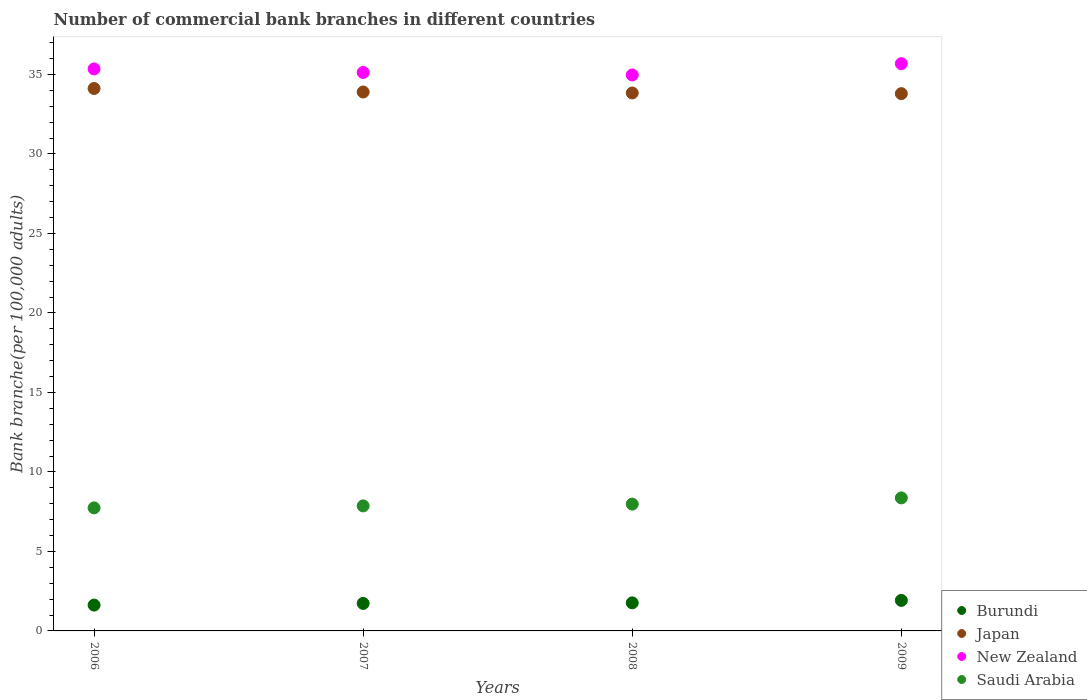Is the number of dotlines equal to the number of legend labels?
Your answer should be very brief. Yes. What is the number of commercial bank branches in Burundi in 2007?
Offer a very short reply. 1.73. Across all years, what is the maximum number of commercial bank branches in Japan?
Offer a terse response. 34.11. Across all years, what is the minimum number of commercial bank branches in Burundi?
Your response must be concise. 1.62. In which year was the number of commercial bank branches in Japan minimum?
Keep it short and to the point. 2009. What is the total number of commercial bank branches in Saudi Arabia in the graph?
Ensure brevity in your answer.  31.94. What is the difference between the number of commercial bank branches in New Zealand in 2008 and that in 2009?
Ensure brevity in your answer.  -0.71. What is the difference between the number of commercial bank branches in Burundi in 2006 and the number of commercial bank branches in Saudi Arabia in 2007?
Offer a very short reply. -6.24. What is the average number of commercial bank branches in Burundi per year?
Provide a short and direct response. 1.76. In the year 2009, what is the difference between the number of commercial bank branches in Japan and number of commercial bank branches in Saudi Arabia?
Your answer should be compact. 25.42. What is the ratio of the number of commercial bank branches in Burundi in 2007 to that in 2008?
Make the answer very short. 0.98. Is the difference between the number of commercial bank branches in Japan in 2007 and 2008 greater than the difference between the number of commercial bank branches in Saudi Arabia in 2007 and 2008?
Offer a very short reply. Yes. What is the difference between the highest and the second highest number of commercial bank branches in Burundi?
Your answer should be compact. 0.15. What is the difference between the highest and the lowest number of commercial bank branches in Saudi Arabia?
Make the answer very short. 0.63. In how many years, is the number of commercial bank branches in New Zealand greater than the average number of commercial bank branches in New Zealand taken over all years?
Your answer should be compact. 2. Is the sum of the number of commercial bank branches in Japan in 2007 and 2008 greater than the maximum number of commercial bank branches in New Zealand across all years?
Provide a short and direct response. Yes. Is it the case that in every year, the sum of the number of commercial bank branches in New Zealand and number of commercial bank branches in Japan  is greater than the sum of number of commercial bank branches in Saudi Arabia and number of commercial bank branches in Burundi?
Make the answer very short. Yes. Is it the case that in every year, the sum of the number of commercial bank branches in Saudi Arabia and number of commercial bank branches in New Zealand  is greater than the number of commercial bank branches in Burundi?
Offer a terse response. Yes. Does the number of commercial bank branches in Japan monotonically increase over the years?
Provide a short and direct response. No. Is the number of commercial bank branches in Japan strictly greater than the number of commercial bank branches in Burundi over the years?
Offer a very short reply. Yes. Is the number of commercial bank branches in New Zealand strictly less than the number of commercial bank branches in Japan over the years?
Provide a short and direct response. No. What is the difference between two consecutive major ticks on the Y-axis?
Your response must be concise. 5. Are the values on the major ticks of Y-axis written in scientific E-notation?
Offer a very short reply. No. What is the title of the graph?
Ensure brevity in your answer.  Number of commercial bank branches in different countries. What is the label or title of the Y-axis?
Your answer should be very brief. Bank branche(per 100,0 adults). What is the Bank branche(per 100,000 adults) of Burundi in 2006?
Your answer should be very brief. 1.62. What is the Bank branche(per 100,000 adults) of Japan in 2006?
Keep it short and to the point. 34.11. What is the Bank branche(per 100,000 adults) in New Zealand in 2006?
Provide a short and direct response. 35.34. What is the Bank branche(per 100,000 adults) in Saudi Arabia in 2006?
Your answer should be very brief. 7.74. What is the Bank branche(per 100,000 adults) in Burundi in 2007?
Provide a short and direct response. 1.73. What is the Bank branche(per 100,000 adults) in Japan in 2007?
Your answer should be compact. 33.89. What is the Bank branche(per 100,000 adults) of New Zealand in 2007?
Give a very brief answer. 35.12. What is the Bank branche(per 100,000 adults) of Saudi Arabia in 2007?
Give a very brief answer. 7.86. What is the Bank branche(per 100,000 adults) in Burundi in 2008?
Provide a succinct answer. 1.76. What is the Bank branche(per 100,000 adults) of Japan in 2008?
Provide a succinct answer. 33.83. What is the Bank branche(per 100,000 adults) of New Zealand in 2008?
Keep it short and to the point. 34.97. What is the Bank branche(per 100,000 adults) in Saudi Arabia in 2008?
Provide a succinct answer. 7.97. What is the Bank branche(per 100,000 adults) in Burundi in 2009?
Offer a very short reply. 1.92. What is the Bank branche(per 100,000 adults) of Japan in 2009?
Your answer should be very brief. 33.79. What is the Bank branche(per 100,000 adults) in New Zealand in 2009?
Give a very brief answer. 35.68. What is the Bank branche(per 100,000 adults) in Saudi Arabia in 2009?
Provide a succinct answer. 8.37. Across all years, what is the maximum Bank branche(per 100,000 adults) of Burundi?
Give a very brief answer. 1.92. Across all years, what is the maximum Bank branche(per 100,000 adults) in Japan?
Make the answer very short. 34.11. Across all years, what is the maximum Bank branche(per 100,000 adults) of New Zealand?
Your response must be concise. 35.68. Across all years, what is the maximum Bank branche(per 100,000 adults) of Saudi Arabia?
Your answer should be compact. 8.37. Across all years, what is the minimum Bank branche(per 100,000 adults) of Burundi?
Offer a very short reply. 1.62. Across all years, what is the minimum Bank branche(per 100,000 adults) in Japan?
Keep it short and to the point. 33.79. Across all years, what is the minimum Bank branche(per 100,000 adults) in New Zealand?
Your response must be concise. 34.97. Across all years, what is the minimum Bank branche(per 100,000 adults) in Saudi Arabia?
Provide a succinct answer. 7.74. What is the total Bank branche(per 100,000 adults) in Burundi in the graph?
Make the answer very short. 7.04. What is the total Bank branche(per 100,000 adults) of Japan in the graph?
Provide a succinct answer. 135.63. What is the total Bank branche(per 100,000 adults) in New Zealand in the graph?
Ensure brevity in your answer.  141.11. What is the total Bank branche(per 100,000 adults) of Saudi Arabia in the graph?
Make the answer very short. 31.94. What is the difference between the Bank branche(per 100,000 adults) in Burundi in 2006 and that in 2007?
Offer a very short reply. -0.11. What is the difference between the Bank branche(per 100,000 adults) in Japan in 2006 and that in 2007?
Offer a terse response. 0.22. What is the difference between the Bank branche(per 100,000 adults) of New Zealand in 2006 and that in 2007?
Ensure brevity in your answer.  0.22. What is the difference between the Bank branche(per 100,000 adults) in Saudi Arabia in 2006 and that in 2007?
Give a very brief answer. -0.13. What is the difference between the Bank branche(per 100,000 adults) in Burundi in 2006 and that in 2008?
Offer a terse response. -0.14. What is the difference between the Bank branche(per 100,000 adults) of Japan in 2006 and that in 2008?
Make the answer very short. 0.28. What is the difference between the Bank branche(per 100,000 adults) of New Zealand in 2006 and that in 2008?
Offer a terse response. 0.38. What is the difference between the Bank branche(per 100,000 adults) in Saudi Arabia in 2006 and that in 2008?
Your answer should be very brief. -0.24. What is the difference between the Bank branche(per 100,000 adults) in Burundi in 2006 and that in 2009?
Offer a very short reply. -0.3. What is the difference between the Bank branche(per 100,000 adults) of Japan in 2006 and that in 2009?
Your answer should be very brief. 0.32. What is the difference between the Bank branche(per 100,000 adults) of New Zealand in 2006 and that in 2009?
Give a very brief answer. -0.33. What is the difference between the Bank branche(per 100,000 adults) in Saudi Arabia in 2006 and that in 2009?
Your answer should be very brief. -0.63. What is the difference between the Bank branche(per 100,000 adults) in Burundi in 2007 and that in 2008?
Your answer should be compact. -0.04. What is the difference between the Bank branche(per 100,000 adults) of Japan in 2007 and that in 2008?
Your response must be concise. 0.06. What is the difference between the Bank branche(per 100,000 adults) in New Zealand in 2007 and that in 2008?
Ensure brevity in your answer.  0.16. What is the difference between the Bank branche(per 100,000 adults) in Saudi Arabia in 2007 and that in 2008?
Give a very brief answer. -0.11. What is the difference between the Bank branche(per 100,000 adults) in Burundi in 2007 and that in 2009?
Give a very brief answer. -0.19. What is the difference between the Bank branche(per 100,000 adults) of Japan in 2007 and that in 2009?
Your answer should be compact. 0.1. What is the difference between the Bank branche(per 100,000 adults) in New Zealand in 2007 and that in 2009?
Keep it short and to the point. -0.55. What is the difference between the Bank branche(per 100,000 adults) of Saudi Arabia in 2007 and that in 2009?
Your answer should be compact. -0.5. What is the difference between the Bank branche(per 100,000 adults) in Burundi in 2008 and that in 2009?
Your answer should be very brief. -0.15. What is the difference between the Bank branche(per 100,000 adults) of Japan in 2008 and that in 2009?
Provide a short and direct response. 0.04. What is the difference between the Bank branche(per 100,000 adults) in New Zealand in 2008 and that in 2009?
Offer a terse response. -0.71. What is the difference between the Bank branche(per 100,000 adults) of Saudi Arabia in 2008 and that in 2009?
Offer a very short reply. -0.39. What is the difference between the Bank branche(per 100,000 adults) in Burundi in 2006 and the Bank branche(per 100,000 adults) in Japan in 2007?
Ensure brevity in your answer.  -32.27. What is the difference between the Bank branche(per 100,000 adults) of Burundi in 2006 and the Bank branche(per 100,000 adults) of New Zealand in 2007?
Provide a short and direct response. -33.5. What is the difference between the Bank branche(per 100,000 adults) of Burundi in 2006 and the Bank branche(per 100,000 adults) of Saudi Arabia in 2007?
Make the answer very short. -6.24. What is the difference between the Bank branche(per 100,000 adults) of Japan in 2006 and the Bank branche(per 100,000 adults) of New Zealand in 2007?
Give a very brief answer. -1.01. What is the difference between the Bank branche(per 100,000 adults) in Japan in 2006 and the Bank branche(per 100,000 adults) in Saudi Arabia in 2007?
Offer a terse response. 26.25. What is the difference between the Bank branche(per 100,000 adults) in New Zealand in 2006 and the Bank branche(per 100,000 adults) in Saudi Arabia in 2007?
Make the answer very short. 27.48. What is the difference between the Bank branche(per 100,000 adults) of Burundi in 2006 and the Bank branche(per 100,000 adults) of Japan in 2008?
Your answer should be compact. -32.21. What is the difference between the Bank branche(per 100,000 adults) of Burundi in 2006 and the Bank branche(per 100,000 adults) of New Zealand in 2008?
Ensure brevity in your answer.  -33.34. What is the difference between the Bank branche(per 100,000 adults) of Burundi in 2006 and the Bank branche(per 100,000 adults) of Saudi Arabia in 2008?
Give a very brief answer. -6.35. What is the difference between the Bank branche(per 100,000 adults) in Japan in 2006 and the Bank branche(per 100,000 adults) in New Zealand in 2008?
Your answer should be compact. -0.85. What is the difference between the Bank branche(per 100,000 adults) in Japan in 2006 and the Bank branche(per 100,000 adults) in Saudi Arabia in 2008?
Your answer should be very brief. 26.14. What is the difference between the Bank branche(per 100,000 adults) in New Zealand in 2006 and the Bank branche(per 100,000 adults) in Saudi Arabia in 2008?
Offer a very short reply. 27.37. What is the difference between the Bank branche(per 100,000 adults) of Burundi in 2006 and the Bank branche(per 100,000 adults) of Japan in 2009?
Provide a short and direct response. -32.17. What is the difference between the Bank branche(per 100,000 adults) in Burundi in 2006 and the Bank branche(per 100,000 adults) in New Zealand in 2009?
Your response must be concise. -34.05. What is the difference between the Bank branche(per 100,000 adults) in Burundi in 2006 and the Bank branche(per 100,000 adults) in Saudi Arabia in 2009?
Provide a succinct answer. -6.74. What is the difference between the Bank branche(per 100,000 adults) in Japan in 2006 and the Bank branche(per 100,000 adults) in New Zealand in 2009?
Keep it short and to the point. -1.56. What is the difference between the Bank branche(per 100,000 adults) of Japan in 2006 and the Bank branche(per 100,000 adults) of Saudi Arabia in 2009?
Give a very brief answer. 25.75. What is the difference between the Bank branche(per 100,000 adults) in New Zealand in 2006 and the Bank branche(per 100,000 adults) in Saudi Arabia in 2009?
Provide a short and direct response. 26.98. What is the difference between the Bank branche(per 100,000 adults) of Burundi in 2007 and the Bank branche(per 100,000 adults) of Japan in 2008?
Keep it short and to the point. -32.1. What is the difference between the Bank branche(per 100,000 adults) of Burundi in 2007 and the Bank branche(per 100,000 adults) of New Zealand in 2008?
Offer a very short reply. -33.24. What is the difference between the Bank branche(per 100,000 adults) in Burundi in 2007 and the Bank branche(per 100,000 adults) in Saudi Arabia in 2008?
Keep it short and to the point. -6.25. What is the difference between the Bank branche(per 100,000 adults) of Japan in 2007 and the Bank branche(per 100,000 adults) of New Zealand in 2008?
Your answer should be compact. -1.07. What is the difference between the Bank branche(per 100,000 adults) of Japan in 2007 and the Bank branche(per 100,000 adults) of Saudi Arabia in 2008?
Provide a short and direct response. 25.92. What is the difference between the Bank branche(per 100,000 adults) of New Zealand in 2007 and the Bank branche(per 100,000 adults) of Saudi Arabia in 2008?
Your response must be concise. 27.15. What is the difference between the Bank branche(per 100,000 adults) in Burundi in 2007 and the Bank branche(per 100,000 adults) in Japan in 2009?
Keep it short and to the point. -32.06. What is the difference between the Bank branche(per 100,000 adults) in Burundi in 2007 and the Bank branche(per 100,000 adults) in New Zealand in 2009?
Ensure brevity in your answer.  -33.95. What is the difference between the Bank branche(per 100,000 adults) in Burundi in 2007 and the Bank branche(per 100,000 adults) in Saudi Arabia in 2009?
Offer a very short reply. -6.64. What is the difference between the Bank branche(per 100,000 adults) of Japan in 2007 and the Bank branche(per 100,000 adults) of New Zealand in 2009?
Keep it short and to the point. -1.78. What is the difference between the Bank branche(per 100,000 adults) of Japan in 2007 and the Bank branche(per 100,000 adults) of Saudi Arabia in 2009?
Give a very brief answer. 25.53. What is the difference between the Bank branche(per 100,000 adults) of New Zealand in 2007 and the Bank branche(per 100,000 adults) of Saudi Arabia in 2009?
Keep it short and to the point. 26.76. What is the difference between the Bank branche(per 100,000 adults) of Burundi in 2008 and the Bank branche(per 100,000 adults) of Japan in 2009?
Provide a short and direct response. -32.03. What is the difference between the Bank branche(per 100,000 adults) in Burundi in 2008 and the Bank branche(per 100,000 adults) in New Zealand in 2009?
Your response must be concise. -33.91. What is the difference between the Bank branche(per 100,000 adults) in Burundi in 2008 and the Bank branche(per 100,000 adults) in Saudi Arabia in 2009?
Keep it short and to the point. -6.6. What is the difference between the Bank branche(per 100,000 adults) of Japan in 2008 and the Bank branche(per 100,000 adults) of New Zealand in 2009?
Offer a very short reply. -1.84. What is the difference between the Bank branche(per 100,000 adults) in Japan in 2008 and the Bank branche(per 100,000 adults) in Saudi Arabia in 2009?
Provide a short and direct response. 25.47. What is the difference between the Bank branche(per 100,000 adults) of New Zealand in 2008 and the Bank branche(per 100,000 adults) of Saudi Arabia in 2009?
Give a very brief answer. 26.6. What is the average Bank branche(per 100,000 adults) of Burundi per year?
Make the answer very short. 1.76. What is the average Bank branche(per 100,000 adults) of Japan per year?
Your answer should be very brief. 33.91. What is the average Bank branche(per 100,000 adults) of New Zealand per year?
Your response must be concise. 35.28. What is the average Bank branche(per 100,000 adults) of Saudi Arabia per year?
Ensure brevity in your answer.  7.99. In the year 2006, what is the difference between the Bank branche(per 100,000 adults) in Burundi and Bank branche(per 100,000 adults) in Japan?
Your answer should be compact. -32.49. In the year 2006, what is the difference between the Bank branche(per 100,000 adults) of Burundi and Bank branche(per 100,000 adults) of New Zealand?
Provide a succinct answer. -33.72. In the year 2006, what is the difference between the Bank branche(per 100,000 adults) of Burundi and Bank branche(per 100,000 adults) of Saudi Arabia?
Your answer should be compact. -6.11. In the year 2006, what is the difference between the Bank branche(per 100,000 adults) of Japan and Bank branche(per 100,000 adults) of New Zealand?
Keep it short and to the point. -1.23. In the year 2006, what is the difference between the Bank branche(per 100,000 adults) of Japan and Bank branche(per 100,000 adults) of Saudi Arabia?
Make the answer very short. 26.38. In the year 2006, what is the difference between the Bank branche(per 100,000 adults) of New Zealand and Bank branche(per 100,000 adults) of Saudi Arabia?
Offer a very short reply. 27.61. In the year 2007, what is the difference between the Bank branche(per 100,000 adults) in Burundi and Bank branche(per 100,000 adults) in Japan?
Your response must be concise. -32.16. In the year 2007, what is the difference between the Bank branche(per 100,000 adults) in Burundi and Bank branche(per 100,000 adults) in New Zealand?
Your answer should be compact. -33.39. In the year 2007, what is the difference between the Bank branche(per 100,000 adults) of Burundi and Bank branche(per 100,000 adults) of Saudi Arabia?
Give a very brief answer. -6.13. In the year 2007, what is the difference between the Bank branche(per 100,000 adults) in Japan and Bank branche(per 100,000 adults) in New Zealand?
Your response must be concise. -1.23. In the year 2007, what is the difference between the Bank branche(per 100,000 adults) of Japan and Bank branche(per 100,000 adults) of Saudi Arabia?
Your answer should be compact. 26.03. In the year 2007, what is the difference between the Bank branche(per 100,000 adults) of New Zealand and Bank branche(per 100,000 adults) of Saudi Arabia?
Ensure brevity in your answer.  27.26. In the year 2008, what is the difference between the Bank branche(per 100,000 adults) in Burundi and Bank branche(per 100,000 adults) in Japan?
Your response must be concise. -32.07. In the year 2008, what is the difference between the Bank branche(per 100,000 adults) in Burundi and Bank branche(per 100,000 adults) in New Zealand?
Make the answer very short. -33.2. In the year 2008, what is the difference between the Bank branche(per 100,000 adults) of Burundi and Bank branche(per 100,000 adults) of Saudi Arabia?
Your response must be concise. -6.21. In the year 2008, what is the difference between the Bank branche(per 100,000 adults) of Japan and Bank branche(per 100,000 adults) of New Zealand?
Give a very brief answer. -1.13. In the year 2008, what is the difference between the Bank branche(per 100,000 adults) in Japan and Bank branche(per 100,000 adults) in Saudi Arabia?
Your response must be concise. 25.86. In the year 2008, what is the difference between the Bank branche(per 100,000 adults) of New Zealand and Bank branche(per 100,000 adults) of Saudi Arabia?
Make the answer very short. 26.99. In the year 2009, what is the difference between the Bank branche(per 100,000 adults) in Burundi and Bank branche(per 100,000 adults) in Japan?
Your response must be concise. -31.87. In the year 2009, what is the difference between the Bank branche(per 100,000 adults) of Burundi and Bank branche(per 100,000 adults) of New Zealand?
Make the answer very short. -33.76. In the year 2009, what is the difference between the Bank branche(per 100,000 adults) of Burundi and Bank branche(per 100,000 adults) of Saudi Arabia?
Provide a short and direct response. -6.45. In the year 2009, what is the difference between the Bank branche(per 100,000 adults) of Japan and Bank branche(per 100,000 adults) of New Zealand?
Keep it short and to the point. -1.89. In the year 2009, what is the difference between the Bank branche(per 100,000 adults) in Japan and Bank branche(per 100,000 adults) in Saudi Arabia?
Give a very brief answer. 25.42. In the year 2009, what is the difference between the Bank branche(per 100,000 adults) of New Zealand and Bank branche(per 100,000 adults) of Saudi Arabia?
Offer a very short reply. 27.31. What is the ratio of the Bank branche(per 100,000 adults) of Burundi in 2006 to that in 2007?
Your answer should be compact. 0.94. What is the ratio of the Bank branche(per 100,000 adults) in Burundi in 2006 to that in 2008?
Keep it short and to the point. 0.92. What is the ratio of the Bank branche(per 100,000 adults) in Japan in 2006 to that in 2008?
Offer a terse response. 1.01. What is the ratio of the Bank branche(per 100,000 adults) of New Zealand in 2006 to that in 2008?
Give a very brief answer. 1.01. What is the ratio of the Bank branche(per 100,000 adults) in Saudi Arabia in 2006 to that in 2008?
Give a very brief answer. 0.97. What is the ratio of the Bank branche(per 100,000 adults) in Burundi in 2006 to that in 2009?
Give a very brief answer. 0.85. What is the ratio of the Bank branche(per 100,000 adults) in Japan in 2006 to that in 2009?
Your answer should be compact. 1.01. What is the ratio of the Bank branche(per 100,000 adults) in New Zealand in 2006 to that in 2009?
Your answer should be very brief. 0.99. What is the ratio of the Bank branche(per 100,000 adults) of Saudi Arabia in 2006 to that in 2009?
Provide a succinct answer. 0.92. What is the ratio of the Bank branche(per 100,000 adults) in Burundi in 2007 to that in 2008?
Ensure brevity in your answer.  0.98. What is the ratio of the Bank branche(per 100,000 adults) of Japan in 2007 to that in 2008?
Provide a short and direct response. 1. What is the ratio of the Bank branche(per 100,000 adults) of New Zealand in 2007 to that in 2008?
Give a very brief answer. 1. What is the ratio of the Bank branche(per 100,000 adults) of Burundi in 2007 to that in 2009?
Keep it short and to the point. 0.9. What is the ratio of the Bank branche(per 100,000 adults) in New Zealand in 2007 to that in 2009?
Provide a succinct answer. 0.98. What is the ratio of the Bank branche(per 100,000 adults) in Saudi Arabia in 2007 to that in 2009?
Your answer should be very brief. 0.94. What is the ratio of the Bank branche(per 100,000 adults) of Burundi in 2008 to that in 2009?
Offer a very short reply. 0.92. What is the ratio of the Bank branche(per 100,000 adults) in Japan in 2008 to that in 2009?
Your answer should be very brief. 1. What is the ratio of the Bank branche(per 100,000 adults) in New Zealand in 2008 to that in 2009?
Provide a short and direct response. 0.98. What is the ratio of the Bank branche(per 100,000 adults) in Saudi Arabia in 2008 to that in 2009?
Your response must be concise. 0.95. What is the difference between the highest and the second highest Bank branche(per 100,000 adults) in Burundi?
Offer a terse response. 0.15. What is the difference between the highest and the second highest Bank branche(per 100,000 adults) in Japan?
Give a very brief answer. 0.22. What is the difference between the highest and the second highest Bank branche(per 100,000 adults) of New Zealand?
Your answer should be compact. 0.33. What is the difference between the highest and the second highest Bank branche(per 100,000 adults) in Saudi Arabia?
Ensure brevity in your answer.  0.39. What is the difference between the highest and the lowest Bank branche(per 100,000 adults) in Burundi?
Ensure brevity in your answer.  0.3. What is the difference between the highest and the lowest Bank branche(per 100,000 adults) of Japan?
Offer a very short reply. 0.32. What is the difference between the highest and the lowest Bank branche(per 100,000 adults) of New Zealand?
Your response must be concise. 0.71. What is the difference between the highest and the lowest Bank branche(per 100,000 adults) of Saudi Arabia?
Provide a succinct answer. 0.63. 